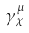<formula> <loc_0><loc_0><loc_500><loc_500>\gamma _ { \chi } ^ { \mu }</formula> 